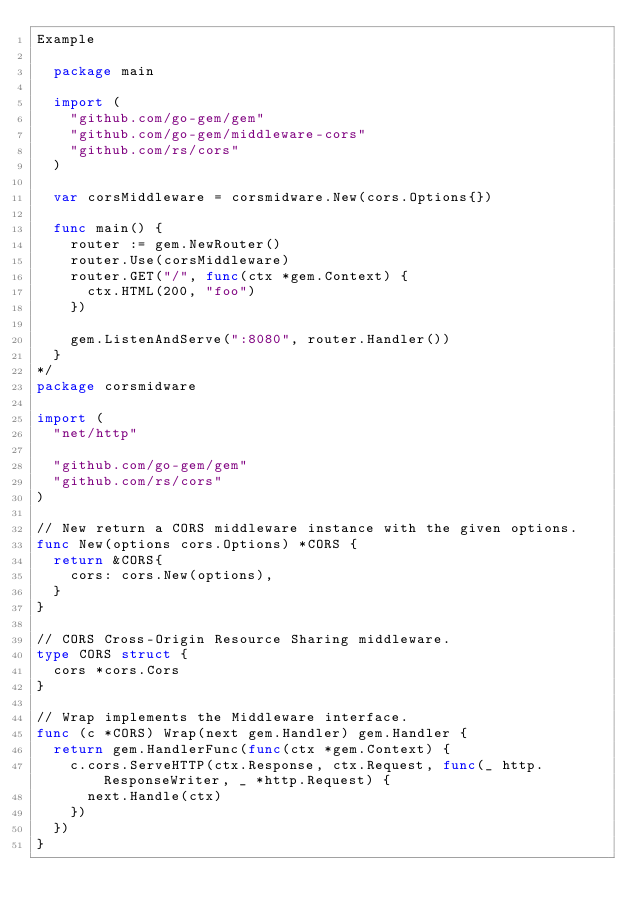Convert code to text. <code><loc_0><loc_0><loc_500><loc_500><_Go_>Example

	package main

	import (
		"github.com/go-gem/gem"
		"github.com/go-gem/middleware-cors"
		"github.com/rs/cors"
	)

	var corsMiddleware = corsmidware.New(cors.Options{})

	func main() {
		router := gem.NewRouter()
		router.Use(corsMiddleware)
		router.GET("/", func(ctx *gem.Context) {
			ctx.HTML(200, "foo")
		})

		gem.ListenAndServe(":8080", router.Handler())
	}
*/
package corsmidware

import (
	"net/http"

	"github.com/go-gem/gem"
	"github.com/rs/cors"
)

// New return a CORS middleware instance with the given options.
func New(options cors.Options) *CORS {
	return &CORS{
		cors: cors.New(options),
	}
}

// CORS Cross-Origin Resource Sharing middleware.
type CORS struct {
	cors *cors.Cors
}

// Wrap implements the Middleware interface.
func (c *CORS) Wrap(next gem.Handler) gem.Handler {
	return gem.HandlerFunc(func(ctx *gem.Context) {
		c.cors.ServeHTTP(ctx.Response, ctx.Request, func(_ http.ResponseWriter, _ *http.Request) {
			next.Handle(ctx)
		})
	})
}
</code> 